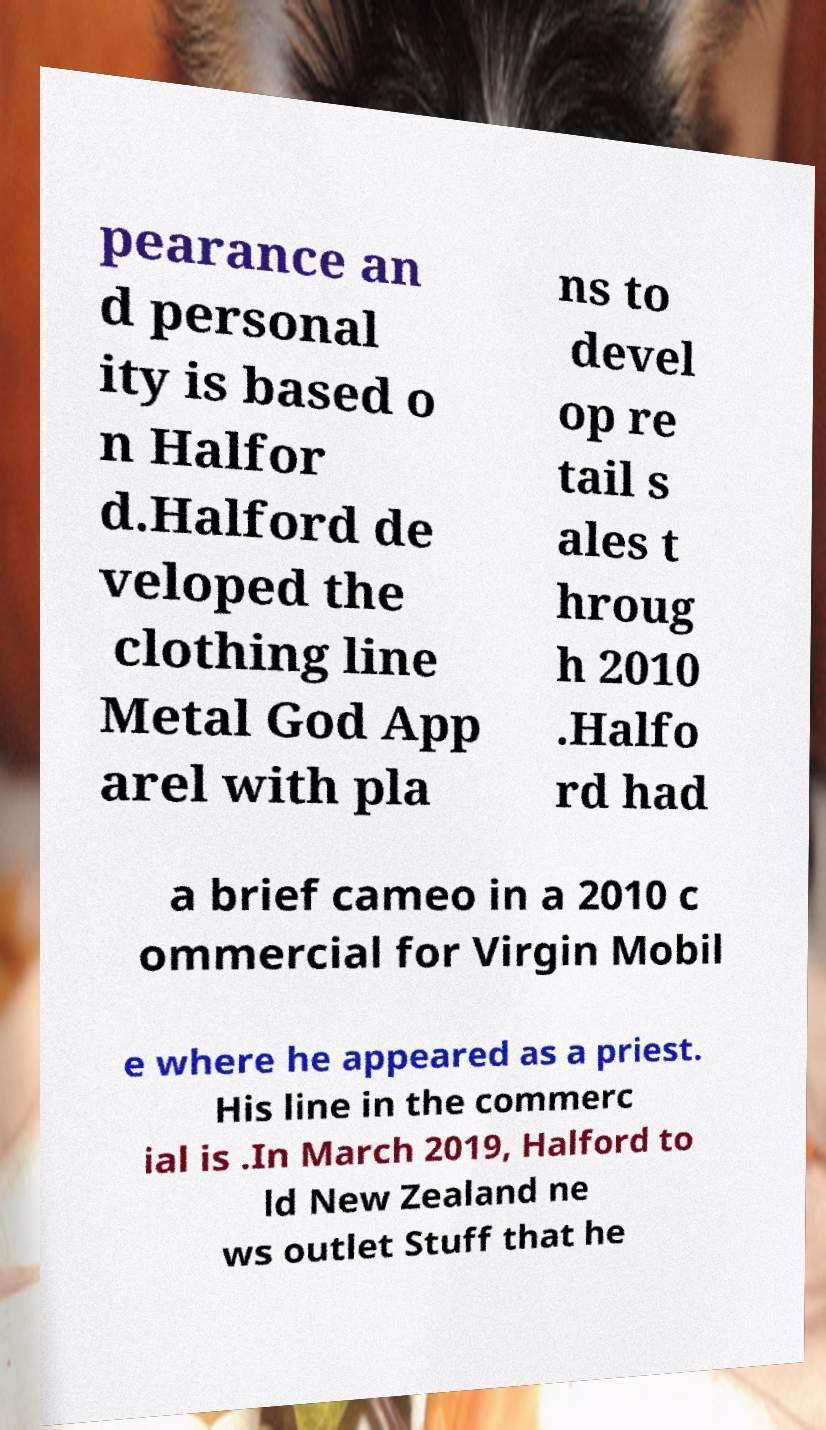Could you assist in decoding the text presented in this image and type it out clearly? pearance an d personal ity is based o n Halfor d.Halford de veloped the clothing line Metal God App arel with pla ns to devel op re tail s ales t hroug h 2010 .Halfo rd had a brief cameo in a 2010 c ommercial for Virgin Mobil e where he appeared as a priest. His line in the commerc ial is .In March 2019, Halford to ld New Zealand ne ws outlet Stuff that he 